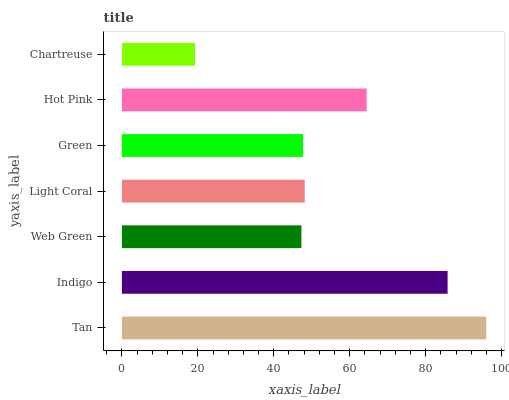Is Chartreuse the minimum?
Answer yes or no. Yes. Is Tan the maximum?
Answer yes or no. Yes. Is Indigo the minimum?
Answer yes or no. No. Is Indigo the maximum?
Answer yes or no. No. Is Tan greater than Indigo?
Answer yes or no. Yes. Is Indigo less than Tan?
Answer yes or no. Yes. Is Indigo greater than Tan?
Answer yes or no. No. Is Tan less than Indigo?
Answer yes or no. No. Is Light Coral the high median?
Answer yes or no. Yes. Is Light Coral the low median?
Answer yes or no. Yes. Is Green the high median?
Answer yes or no. No. Is Hot Pink the low median?
Answer yes or no. No. 